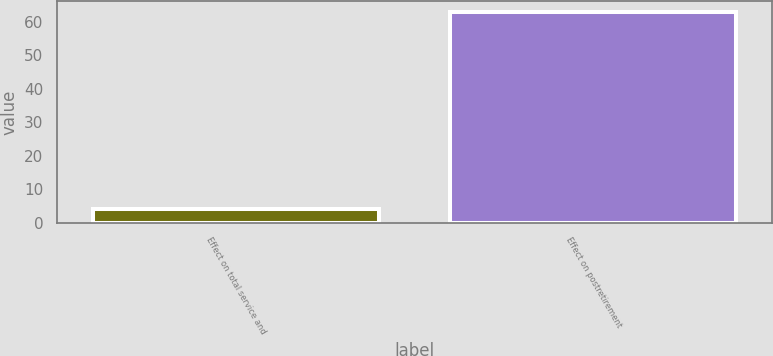Convert chart. <chart><loc_0><loc_0><loc_500><loc_500><bar_chart><fcel>Effect on total service and<fcel>Effect on postretirement<nl><fcel>4<fcel>63<nl></chart> 